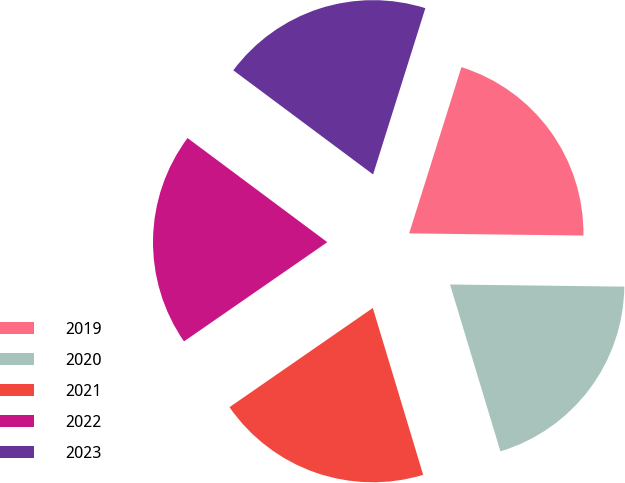<chart> <loc_0><loc_0><loc_500><loc_500><pie_chart><fcel>2019<fcel>2020<fcel>2021<fcel>2022<fcel>2023<nl><fcel>20.35%<fcel>20.14%<fcel>20.03%<fcel>19.83%<fcel>19.66%<nl></chart> 